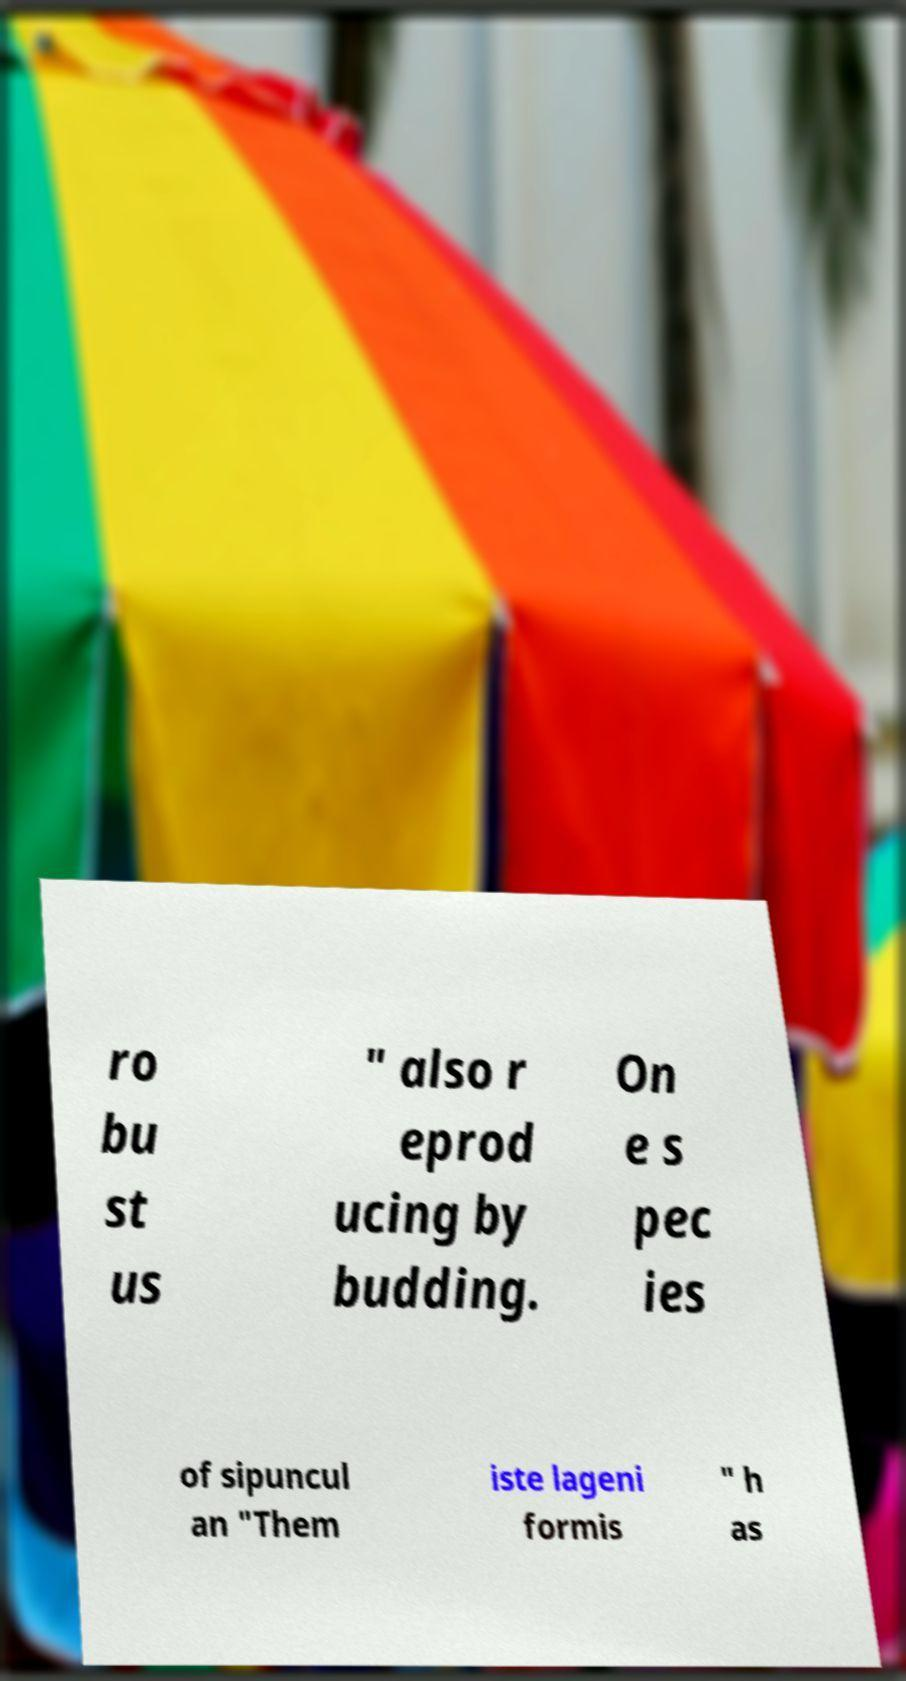Can you accurately transcribe the text from the provided image for me? ro bu st us " also r eprod ucing by budding. On e s pec ies of sipuncul an "Them iste lageni formis " h as 